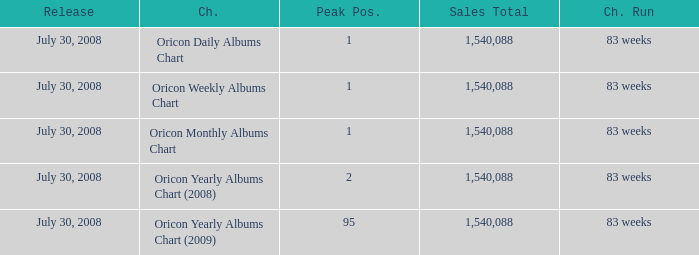Which Chart has a Peak Position of 1? Oricon Daily Albums Chart, Oricon Weekly Albums Chart, Oricon Monthly Albums Chart. 